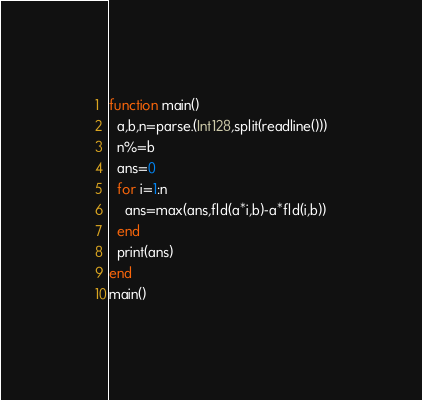<code> <loc_0><loc_0><loc_500><loc_500><_Julia_>function main()
  a,b,n=parse.(Int128,split(readline()))
  n%=b
  ans=0
  for i=1:n
    ans=max(ans,fld(a*i,b)-a*fld(i,b))
  end
  print(ans)
end
main()</code> 